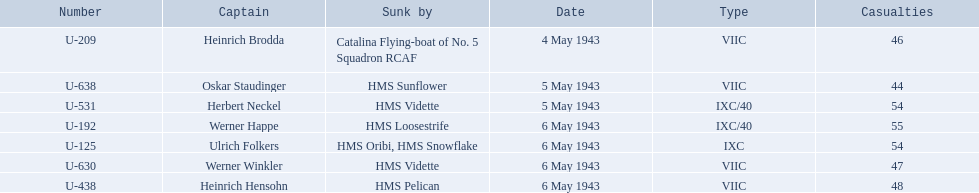Who are all of the captains? Heinrich Brodda, Oskar Staudinger, Herbert Neckel, Werner Happe, Ulrich Folkers, Werner Winkler, Heinrich Hensohn. What sunk each of the captains? Catalina Flying-boat of No. 5 Squadron RCAF, HMS Sunflower, HMS Vidette, HMS Loosestrife, HMS Oribi, HMS Snowflake, HMS Vidette, HMS Pelican. Which was sunk by the hms pelican? Heinrich Hensohn. 